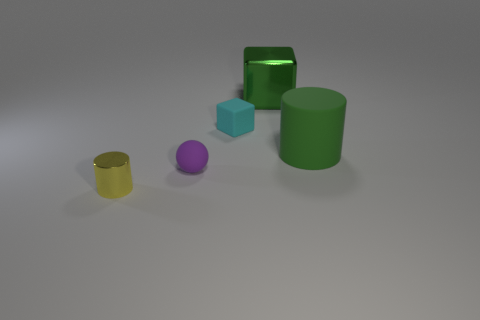Subtract all red cubes. Subtract all cyan balls. How many cubes are left? 2 Add 2 tiny gray rubber cubes. How many objects exist? 7 Subtract all spheres. How many objects are left? 4 Add 4 large gray rubber cylinders. How many large gray rubber cylinders exist? 4 Subtract 0 blue blocks. How many objects are left? 5 Subtract all tiny yellow things. Subtract all purple shiny cylinders. How many objects are left? 4 Add 4 small rubber things. How many small rubber things are left? 6 